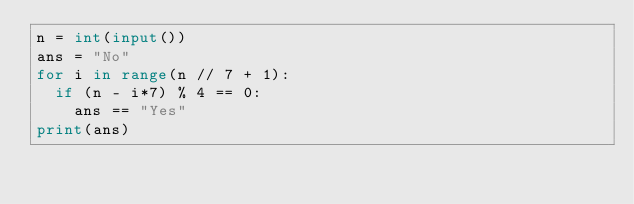Convert code to text. <code><loc_0><loc_0><loc_500><loc_500><_Python_>n = int(input())
ans = "No"
for i in range(n // 7 + 1):
  if (n - i*7) % 4 == 0:
    ans == "Yes"
print(ans)
</code> 